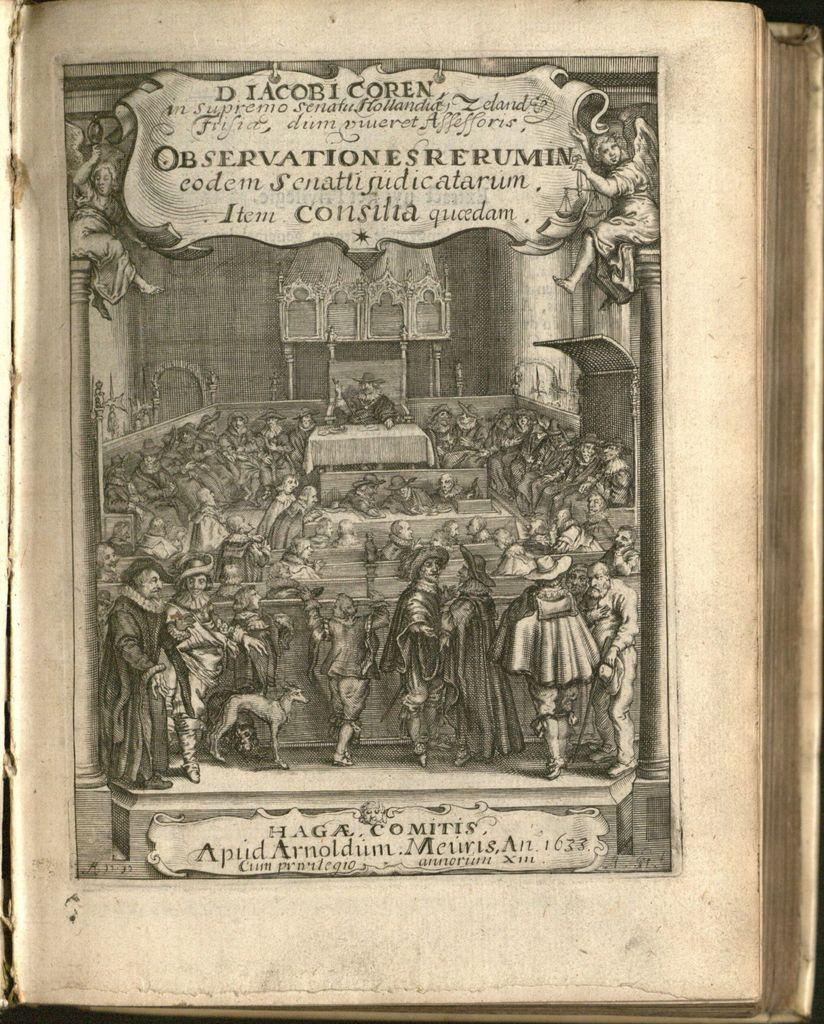<image>
Share a concise interpretation of the image provided. A black and white photo from an old book showing a courthouse scene  with "D IacobI Coren" at the top of the page. 